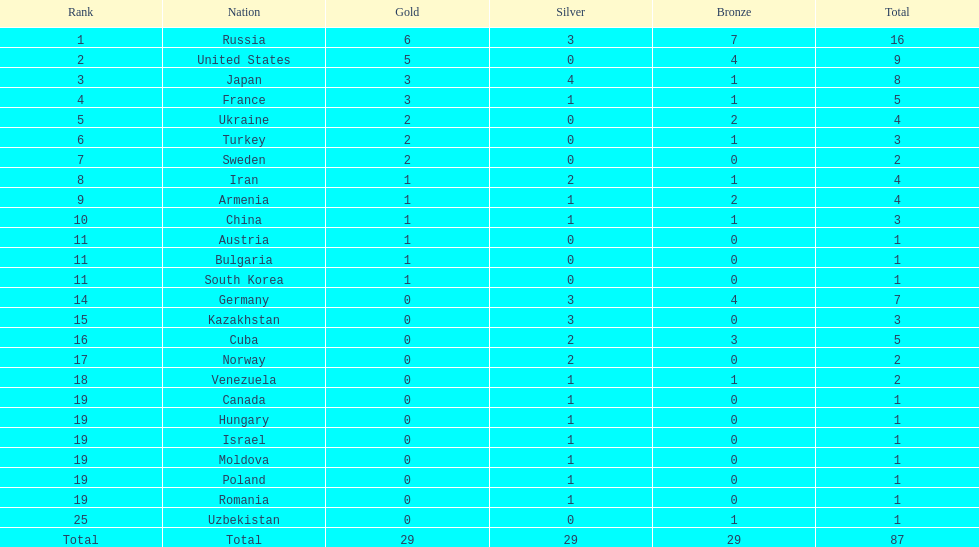Japan and france each won how many gold medals? 3. 